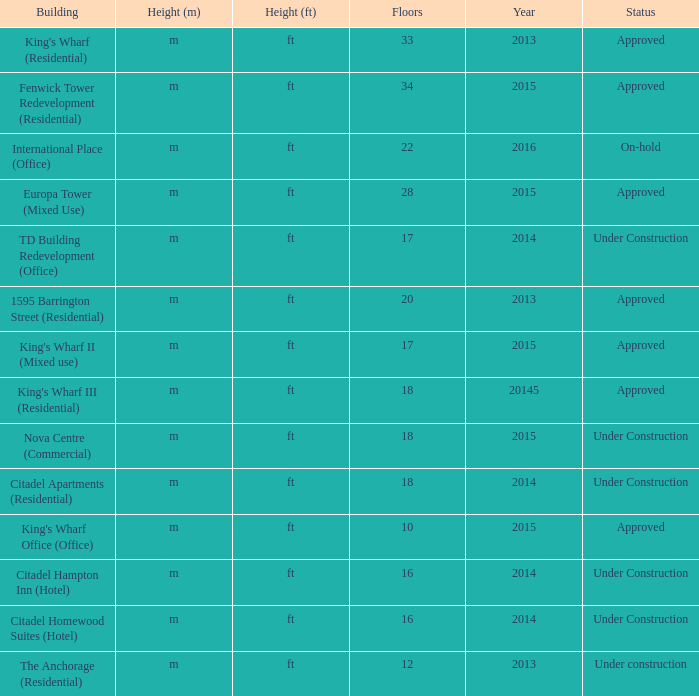What building shows 2013 and has more than 20 floors? King's Wharf (Residential). 